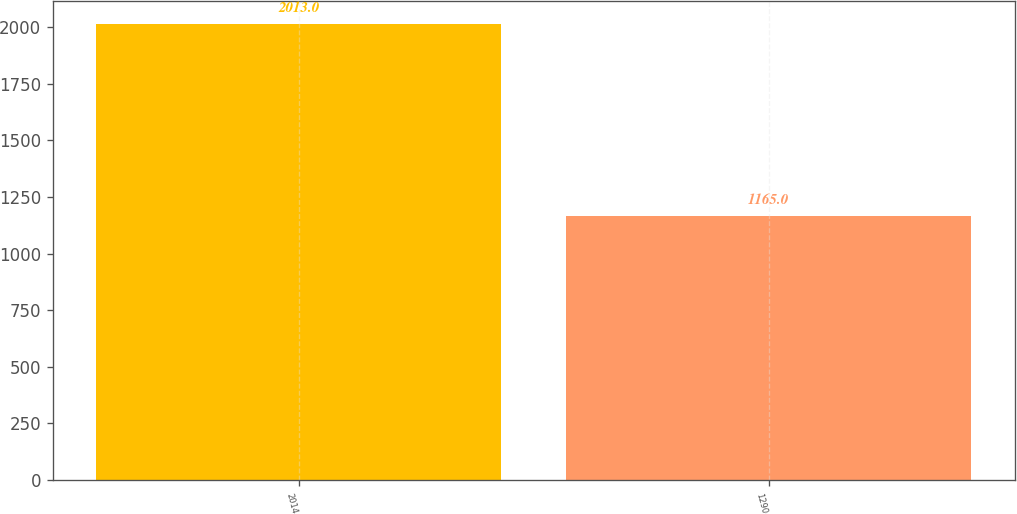<chart> <loc_0><loc_0><loc_500><loc_500><bar_chart><fcel>2014<fcel>1290<nl><fcel>2013<fcel>1165<nl></chart> 